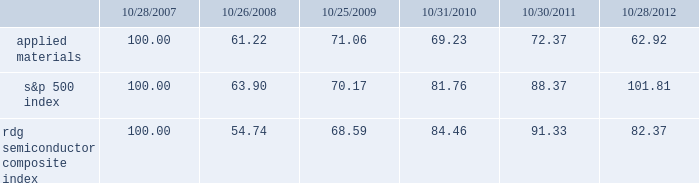Performance graph the performance graph below shows the five-year cumulative total stockholder return on applied common stock during the period from october 28 , 2007 through october 28 , 2012 .
This is compared with the cumulative total return of the standard & poor 2019s 500 stock index and the rdg semiconductor composite index over the same period .
The comparison assumes $ 100 was invested on october 28 , 2007 in applied common stock and in each of the foregoing indices and assumes reinvestment of dividends , if any .
Dollar amounts in the graph are rounded to the nearest whole dollar .
The performance shown in the graph represents past performance and should not be considered an indication of future performance .
Comparison of 5 year cumulative total return* among applied materials , inc. , the s&p 500 index and the rdg semiconductor composite index * $ 100 invested on 10/28/07 in stock or 10/31/07 in index , including reinvestment of dividends .
Indexes calculated on month-end basis .
Copyright a9 2012 s&p , a division of the mcgraw-hill companies inc .
All rights reserved. .
Dividends during fiscal 2012 , applied 2019s board of directors declared three quarterly cash dividends in the amount of $ 0.09 per share each and one quarterly cash dividend in the amount of $ 0.08 per share .
During fiscal 2011 , applied 2019s board of directors declared three quarterly cash dividends in the amount of $ 0.08 per share each and one quarterly cash dividend in the amount of $ 0.07 per share .
During fiscal 2010 , applied 2019s board of directors declared three quarterly cash dividends in the amount of $ 0.07 per share each and one quarterly cash dividend in the amount of $ 0.06 .
Dividends declared during fiscal 2012 , 2011 and 2010 amounted to $ 438 million , $ 408 million and $ 361 million , respectively .
Applied currently anticipates that it will continue to pay cash dividends on a quarterly basis in the future , although the declaration and amount of any future cash dividends are at the discretion of the board of directors and will depend on applied 2019s financial condition , results of operations , capital requirements , business conditions and other factors , as well as a determination that cash dividends are in the best interests of applied 2019s stockholders .
10/28/07 10/26/08 10/25/09 10/31/10 10/30/11 10/28/12 applied materials , inc .
S&p 500 rdg semiconductor composite .
How much did the quarterly dividend yield change from 2010 to 2012 for applied materials? 
Rationale: to figure out the dividend yield one must take the dividend amount and divide by the stock price . in this example , once you find both dividend yields you need to subtract the smaller one from the larger one to get 0.04% .
Computations: ((0.09 / 62.92) - (0.07 / 69.23))
Answer: 0.00042. 